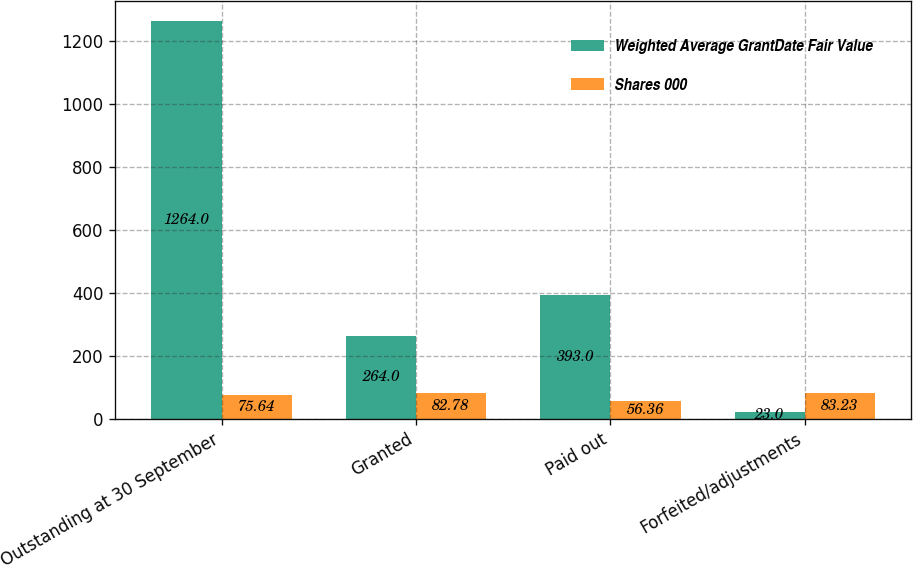Convert chart. <chart><loc_0><loc_0><loc_500><loc_500><stacked_bar_chart><ecel><fcel>Outstanding at 30 September<fcel>Granted<fcel>Paid out<fcel>Forfeited/adjustments<nl><fcel>Weighted Average GrantDate Fair Value<fcel>1264<fcel>264<fcel>393<fcel>23<nl><fcel>Shares 000<fcel>75.64<fcel>82.78<fcel>56.36<fcel>83.23<nl></chart> 